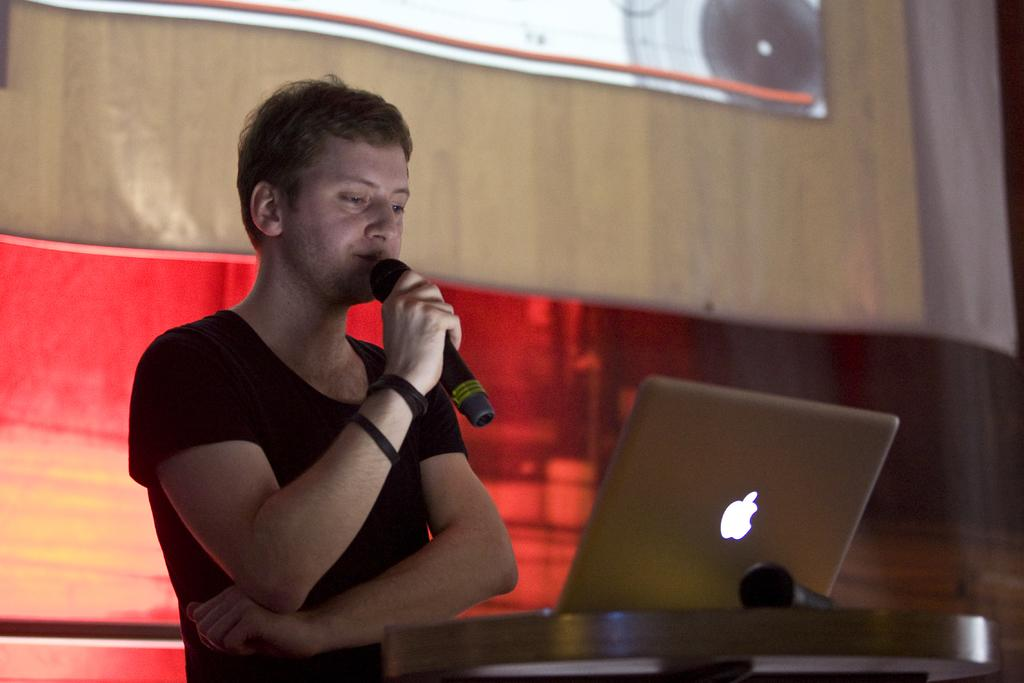Who or what is in the image? There is a person in the image. What is the person doing in the image? The person is catching a microphone. Where is the person standing in relation to other objects in the image? The person is standing in front of a table. What can be seen on the table in the image? There is a laptop on the table. What is behind the person in the image? There is a wall behind the person. What type of bait is the person using to catch the microphone in the image? There is no bait present in the image, as the person is catching a microphone, not a fish or other animal. 